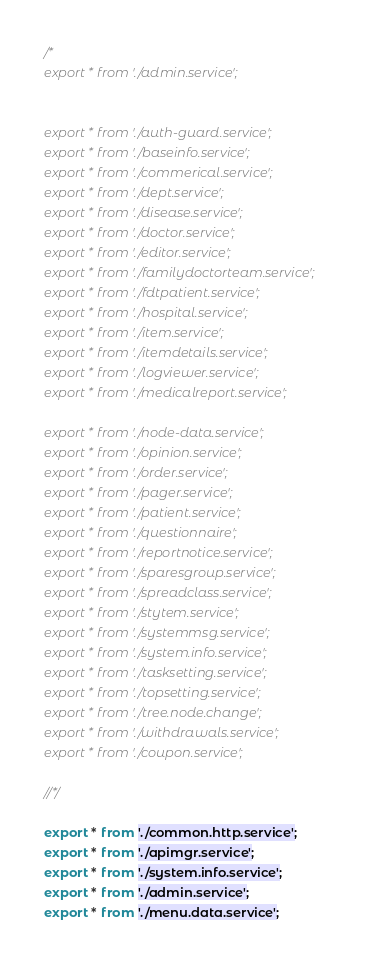Convert code to text. <code><loc_0><loc_0><loc_500><loc_500><_TypeScript_>/*
export * from './admin.service';


export * from './auth-guard.service';
export * from './baseinfo.service';
export * from './commerical.service';
export * from './dept.service';
export * from './disease.service';
export * from './doctor.service';
export * from './editor.service';
export * from './familydoctorteam.service';
export * from './fdtpatient.service';
export * from './hospital.service';
export * from './item.service';
export * from './itemdetails.service';
export * from './logviewer.service';
export * from './medicalreport.service';

export * from './node-data.service';
export * from './opinion.service';
export * from './order.service';
export * from './pager.service';
export * from './patient.service';
export * from './questionnaire';
export * from './reportnotice.service';
export * from './sparesgroup.service';
export * from './spreadclass.service';
export * from './stytem.service';
export * from './systemmsg.service';
export * from './system.info.service';
export * from './tasksetting.service';
export * from './topsetting.service';
export * from './tree.node.change';
export * from './withdrawals.service';
export * from './coupon.service';

//*/

export * from './common.http.service';
export * from './apimgr.service';
export * from './system.info.service';
export * from './admin.service';
export * from './menu.data.service';
</code> 